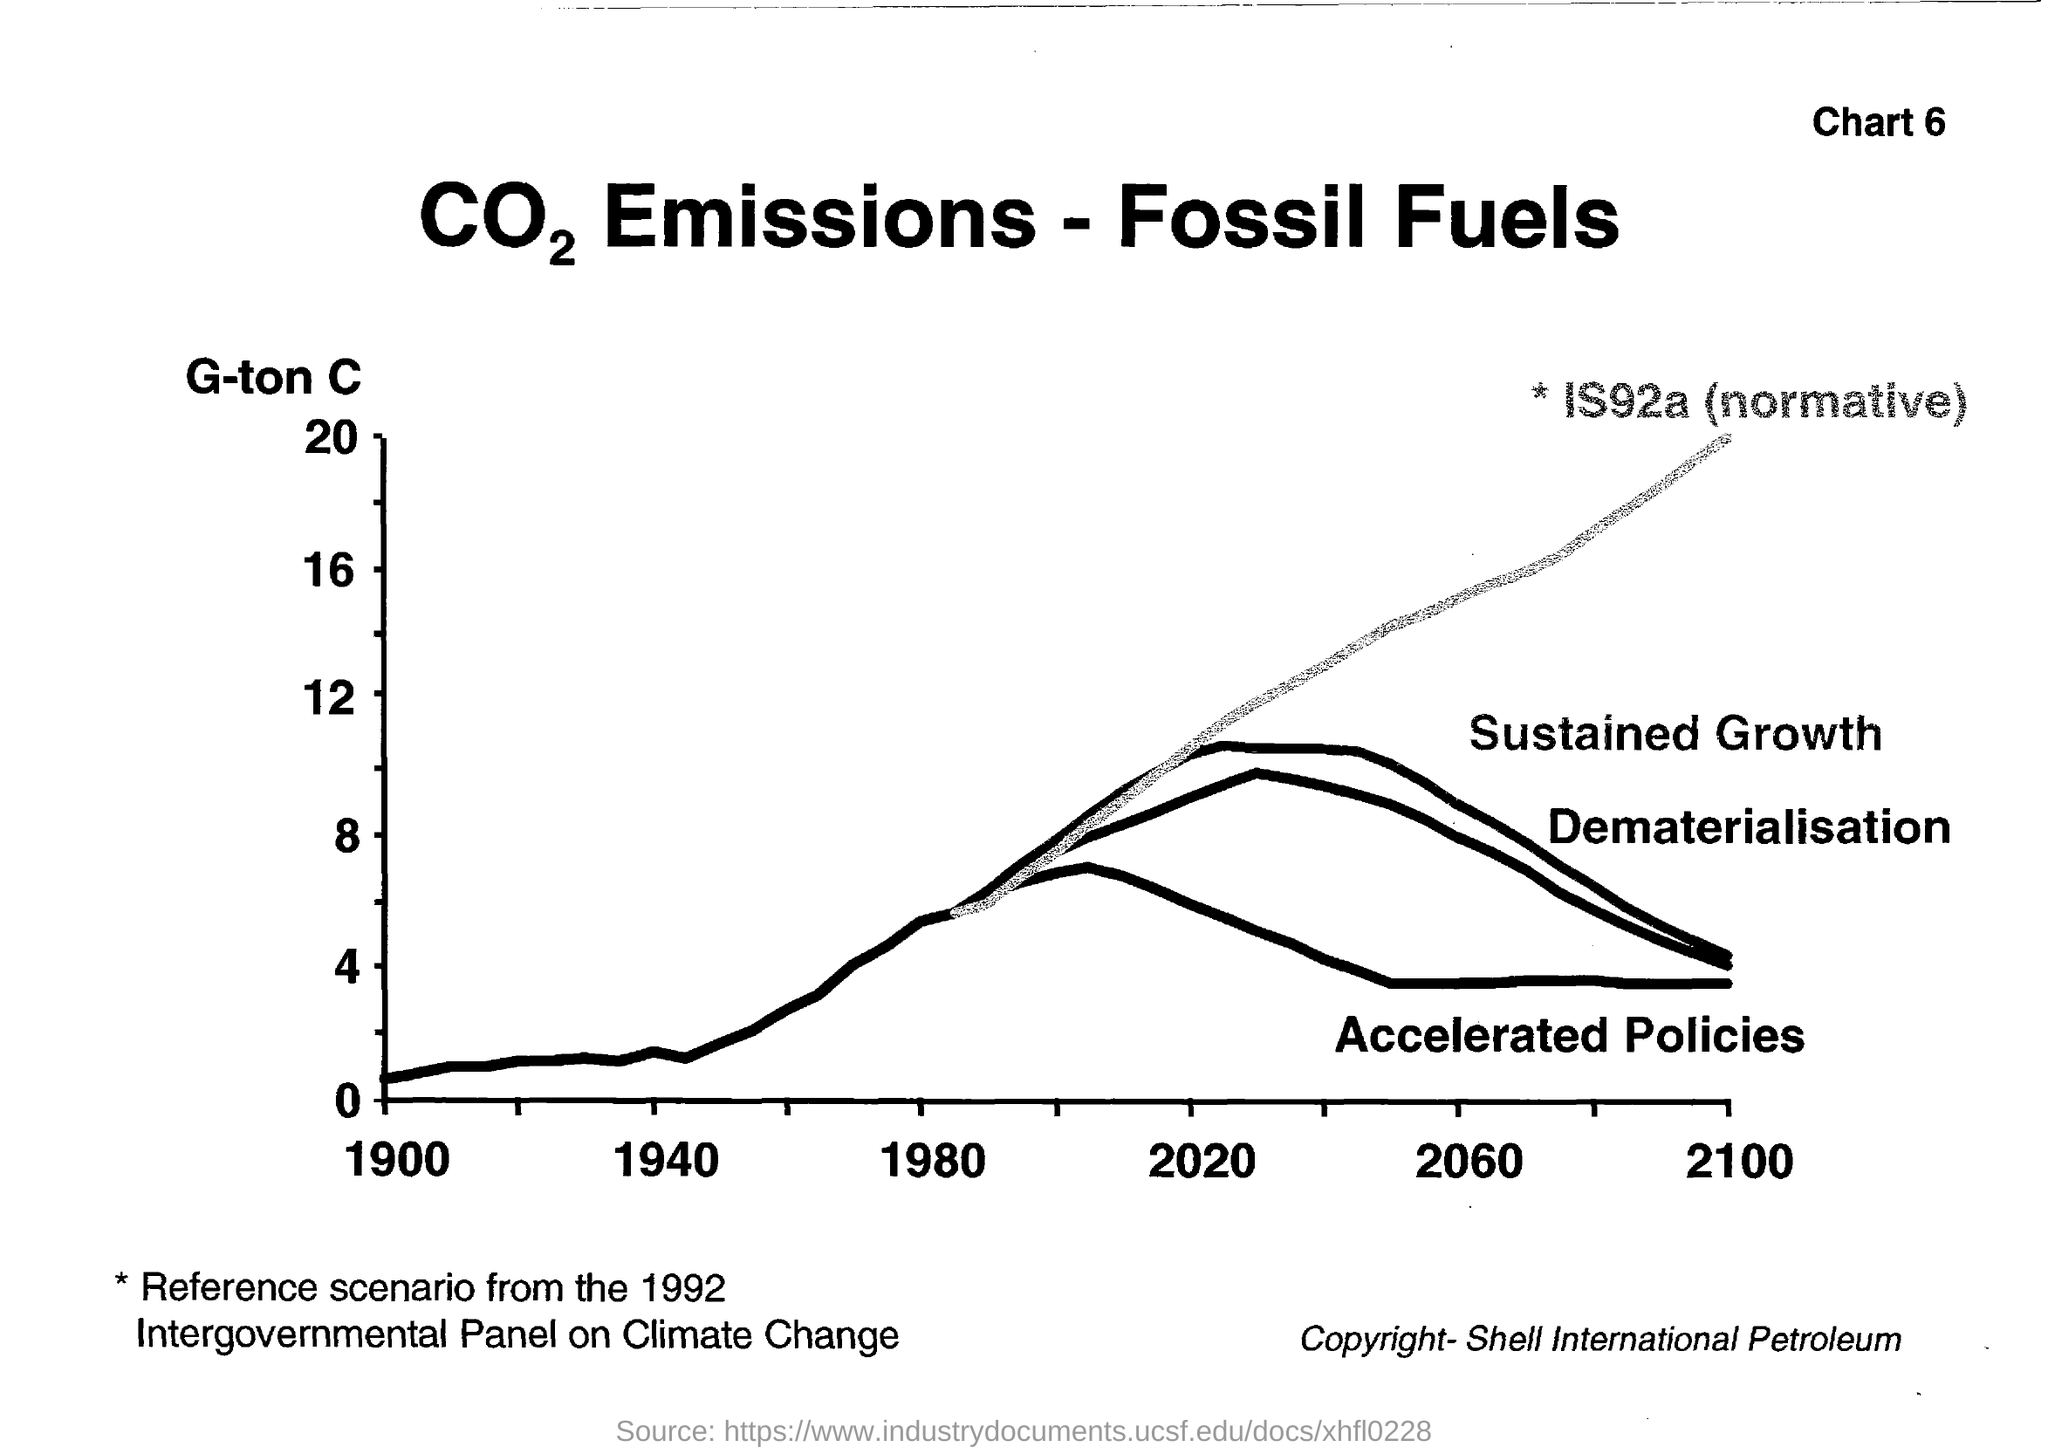Mention a couple of crucial points in this snapshot. The reference scenario for climate change is chosen from the 1992 Intergovernmental Panel on Climate Change. The copyright for this document belongs to Shell International Petroleum. In 2100, the concept of sustained growth and dematerialization will be the same. The specified chart number in the header is "Chart 6. Please provide the highest value in the Y-axis, ranging from 20. 